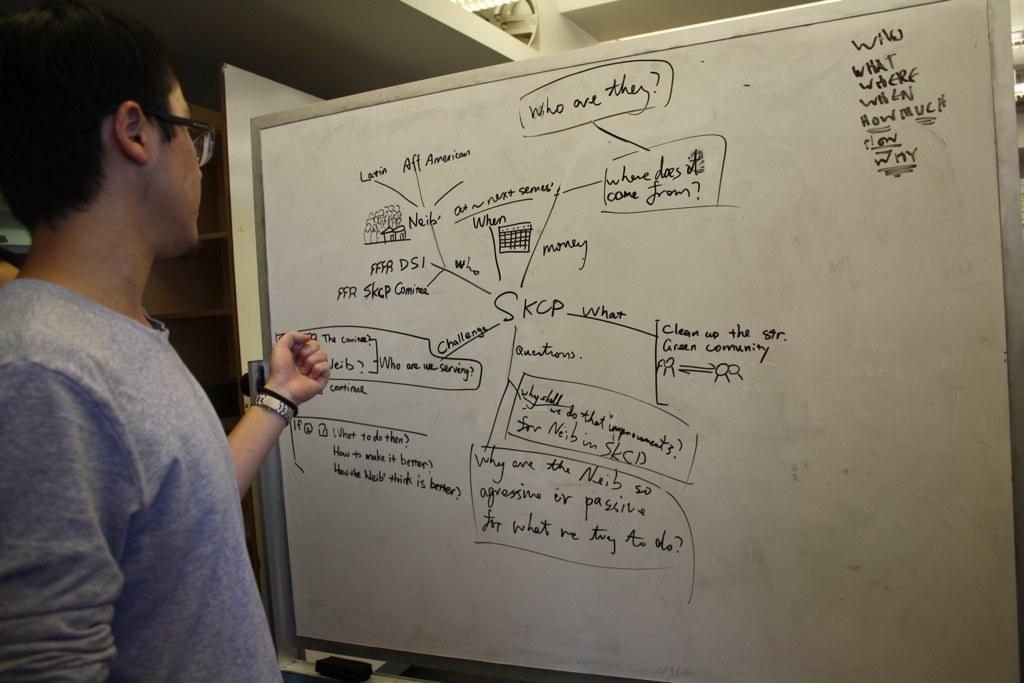Describe this image in one or two sentences. On the left side of the image, we can see a person standing near the white board. On the board we can see some text and figures. On the left side of the image, we can see racks. At the top of the image, we can see few objects. At the bottom of the image, there is a black object. 